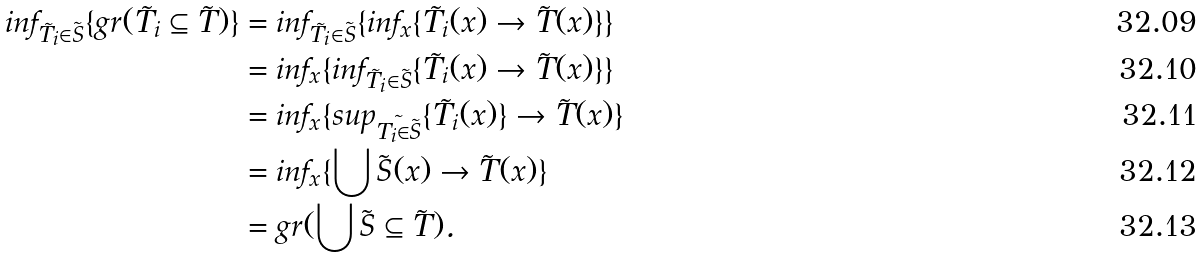<formula> <loc_0><loc_0><loc_500><loc_500>i n f _ { \tilde { T _ { i } } \in \tilde { S } } \{ g r ( \tilde { T _ { i } } \subseteq \tilde { T } ) \} & = i n f _ { \tilde { T _ { i } } \in \tilde { S } } \{ i n f _ { x } \{ \tilde { T _ { i } } ( x ) \rightarrow \tilde { T } ( x ) \} \} \\ & = i n f _ { x } \{ i n f _ { \tilde { T _ { i } } \in \tilde { S } } \{ \tilde { T _ { i } } ( x ) \rightarrow \tilde { T } ( x ) \} \} \\ & = i n f _ { x } \{ s u p _ { \tilde { T _ { i } \in \tilde { S } } } \{ \tilde { T _ { i } } ( x ) \} \rightarrow \tilde { T } ( x ) \} \\ & = i n f _ { x } \{ \bigcup \tilde { S } ( x ) \rightarrow \tilde { T } ( x ) \} \\ & = g r ( \bigcup \tilde { S } \subseteq \tilde { T } ) .</formula> 